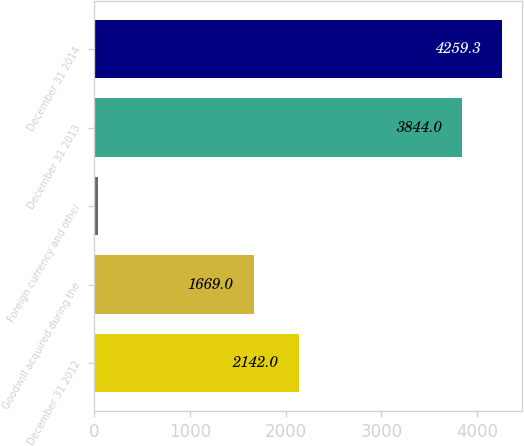Convert chart to OTSL. <chart><loc_0><loc_0><loc_500><loc_500><bar_chart><fcel>December 31 2012<fcel>Goodwill acquired during the<fcel>Foreign currency and other<fcel>December 31 2013<fcel>December 31 2014<nl><fcel>2142<fcel>1669<fcel>33<fcel>3844<fcel>4259.3<nl></chart> 